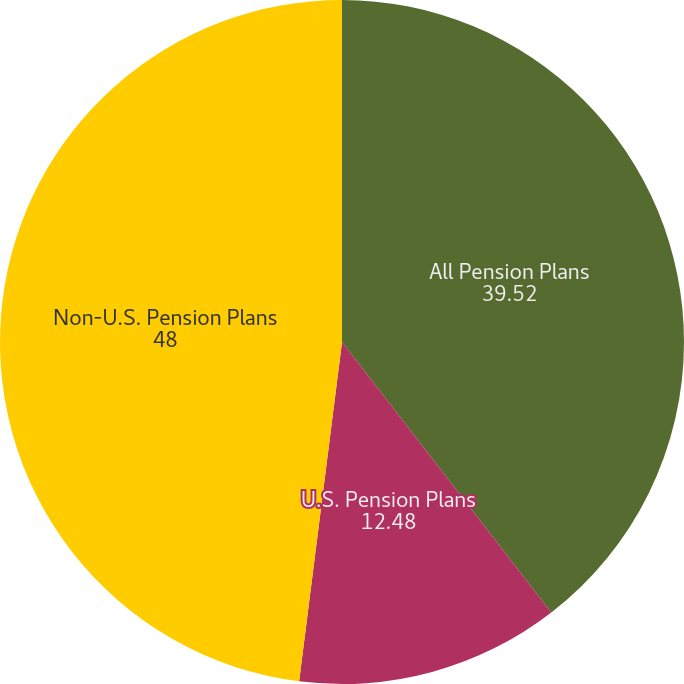Convert chart to OTSL. <chart><loc_0><loc_0><loc_500><loc_500><pie_chart><fcel>All Pension Plans<fcel>U.S. Pension Plans<fcel>Non-U.S. Pension Plans<nl><fcel>39.52%<fcel>12.48%<fcel>48.0%<nl></chart> 